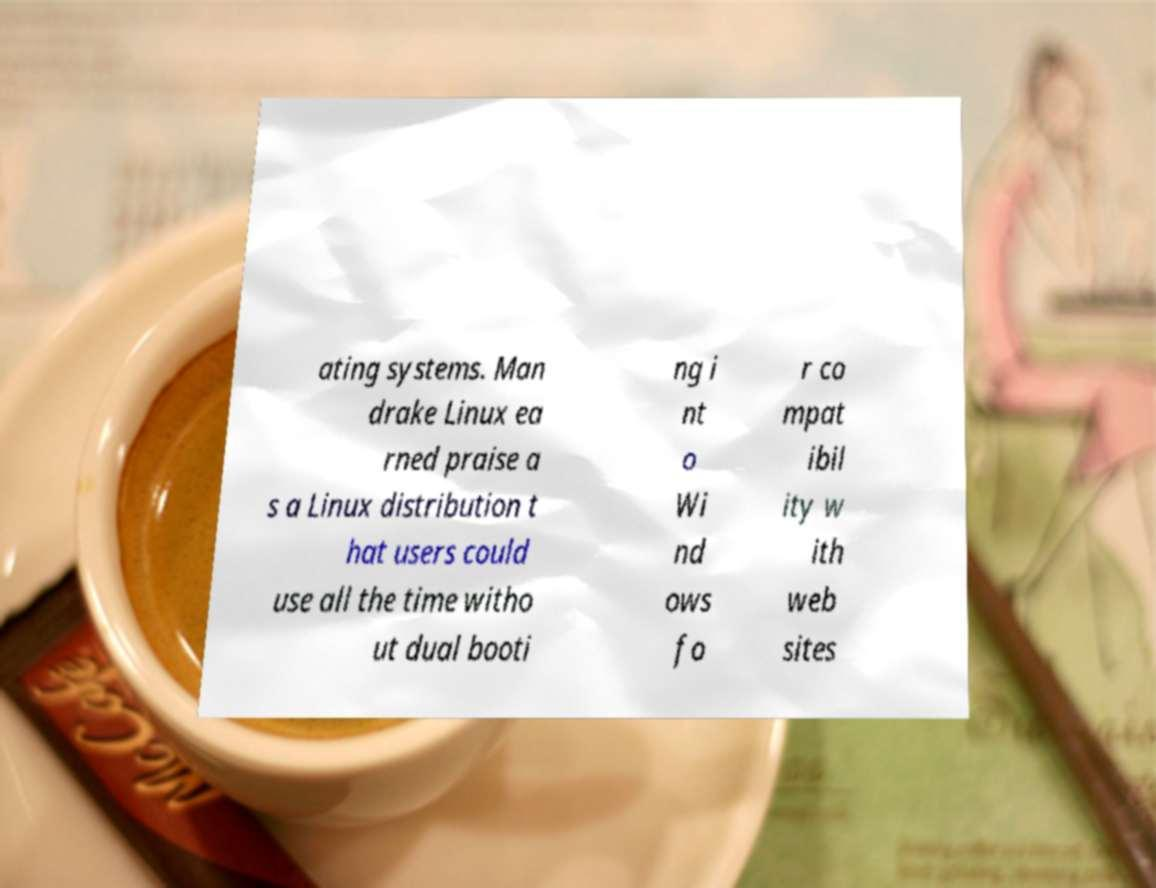I need the written content from this picture converted into text. Can you do that? ating systems. Man drake Linux ea rned praise a s a Linux distribution t hat users could use all the time witho ut dual booti ng i nt o Wi nd ows fo r co mpat ibil ity w ith web sites 